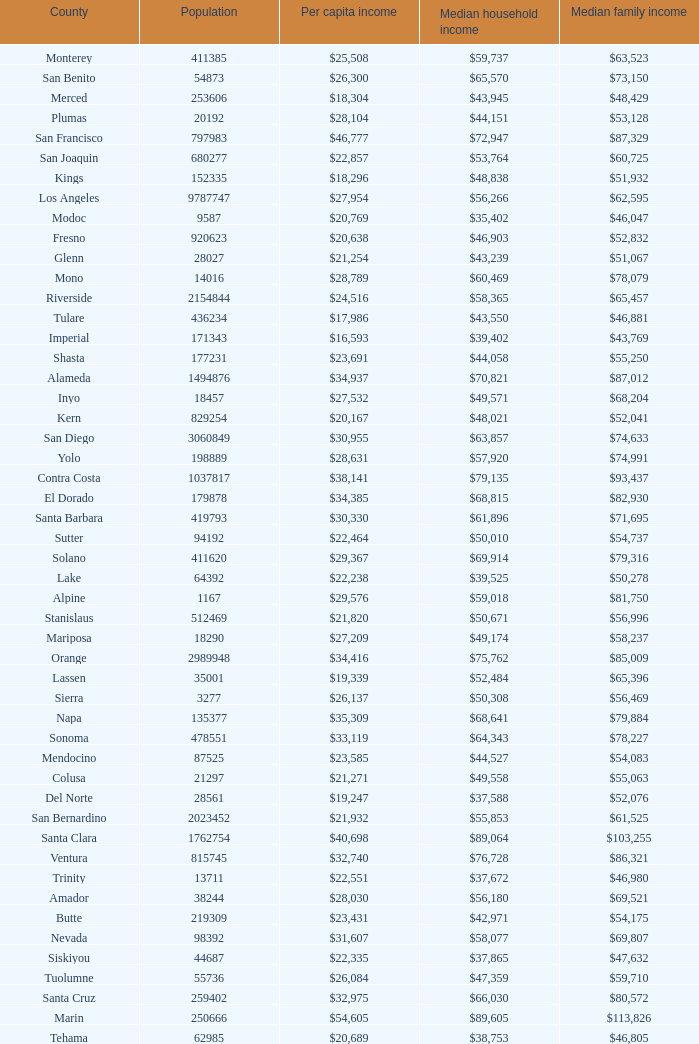What is the median household income of sacramento? $56,553. 